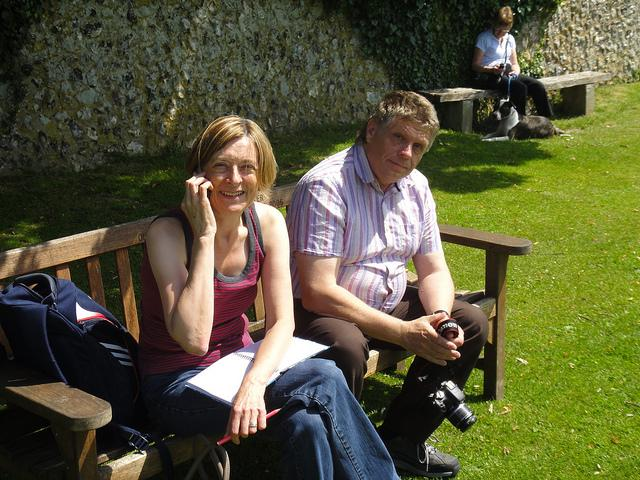What is the woman wearing sleeveless shirt doing? Please explain your reasoning. using phone. The woman has a mobile device in her hand. she is having a conversation with someone else. 